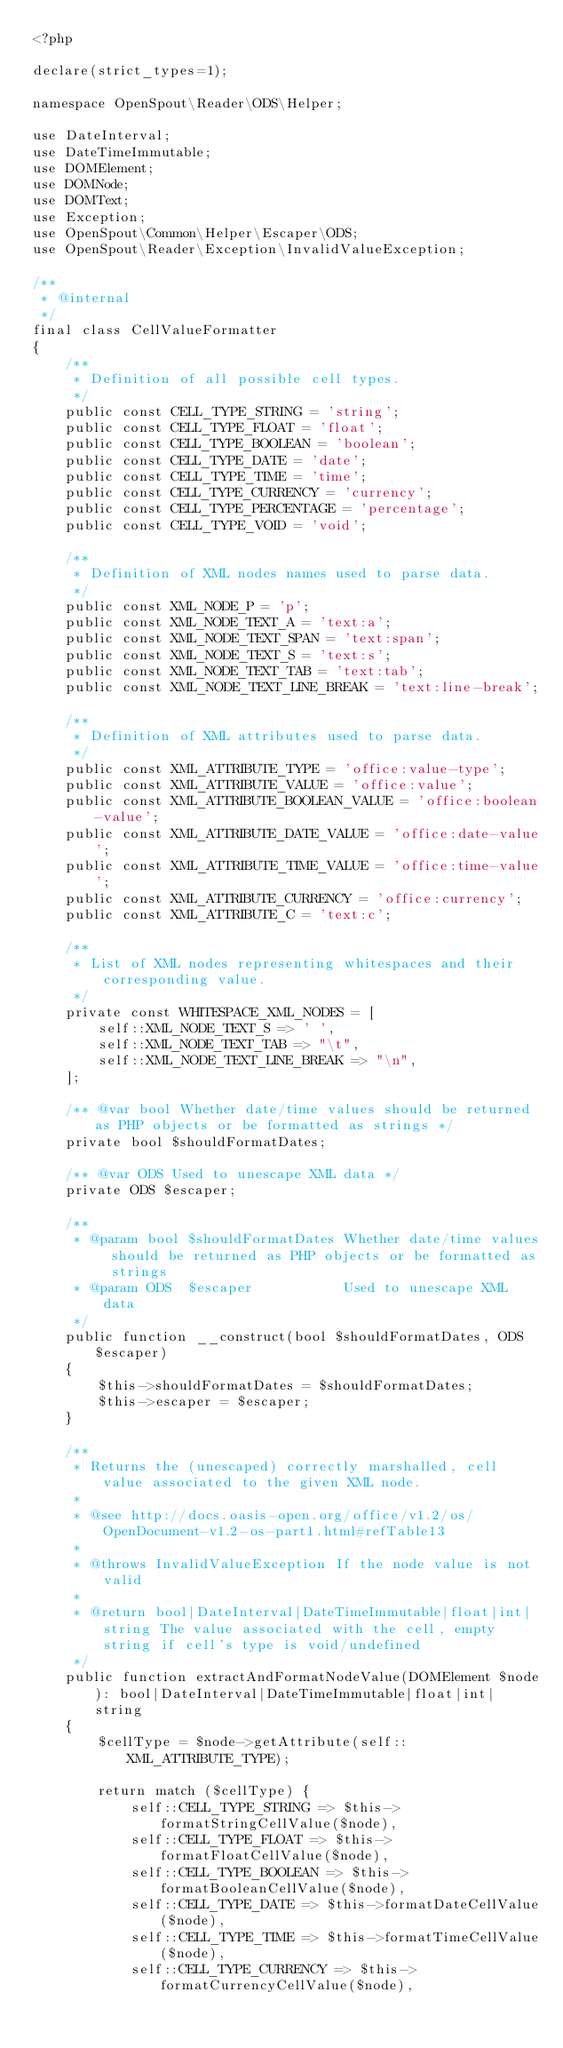Convert code to text. <code><loc_0><loc_0><loc_500><loc_500><_PHP_><?php

declare(strict_types=1);

namespace OpenSpout\Reader\ODS\Helper;

use DateInterval;
use DateTimeImmutable;
use DOMElement;
use DOMNode;
use DOMText;
use Exception;
use OpenSpout\Common\Helper\Escaper\ODS;
use OpenSpout\Reader\Exception\InvalidValueException;

/**
 * @internal
 */
final class CellValueFormatter
{
    /**
     * Definition of all possible cell types.
     */
    public const CELL_TYPE_STRING = 'string';
    public const CELL_TYPE_FLOAT = 'float';
    public const CELL_TYPE_BOOLEAN = 'boolean';
    public const CELL_TYPE_DATE = 'date';
    public const CELL_TYPE_TIME = 'time';
    public const CELL_TYPE_CURRENCY = 'currency';
    public const CELL_TYPE_PERCENTAGE = 'percentage';
    public const CELL_TYPE_VOID = 'void';

    /**
     * Definition of XML nodes names used to parse data.
     */
    public const XML_NODE_P = 'p';
    public const XML_NODE_TEXT_A = 'text:a';
    public const XML_NODE_TEXT_SPAN = 'text:span';
    public const XML_NODE_TEXT_S = 'text:s';
    public const XML_NODE_TEXT_TAB = 'text:tab';
    public const XML_NODE_TEXT_LINE_BREAK = 'text:line-break';

    /**
     * Definition of XML attributes used to parse data.
     */
    public const XML_ATTRIBUTE_TYPE = 'office:value-type';
    public const XML_ATTRIBUTE_VALUE = 'office:value';
    public const XML_ATTRIBUTE_BOOLEAN_VALUE = 'office:boolean-value';
    public const XML_ATTRIBUTE_DATE_VALUE = 'office:date-value';
    public const XML_ATTRIBUTE_TIME_VALUE = 'office:time-value';
    public const XML_ATTRIBUTE_CURRENCY = 'office:currency';
    public const XML_ATTRIBUTE_C = 'text:c';

    /**
     * List of XML nodes representing whitespaces and their corresponding value.
     */
    private const WHITESPACE_XML_NODES = [
        self::XML_NODE_TEXT_S => ' ',
        self::XML_NODE_TEXT_TAB => "\t",
        self::XML_NODE_TEXT_LINE_BREAK => "\n",
    ];

    /** @var bool Whether date/time values should be returned as PHP objects or be formatted as strings */
    private bool $shouldFormatDates;

    /** @var ODS Used to unescape XML data */
    private ODS $escaper;

    /**
     * @param bool $shouldFormatDates Whether date/time values should be returned as PHP objects or be formatted as strings
     * @param ODS  $escaper           Used to unescape XML data
     */
    public function __construct(bool $shouldFormatDates, ODS $escaper)
    {
        $this->shouldFormatDates = $shouldFormatDates;
        $this->escaper = $escaper;
    }

    /**
     * Returns the (unescaped) correctly marshalled, cell value associated to the given XML node.
     *
     * @see http://docs.oasis-open.org/office/v1.2/os/OpenDocument-v1.2-os-part1.html#refTable13
     *
     * @throws InvalidValueException If the node value is not valid
     *
     * @return bool|DateInterval|DateTimeImmutable|float|int|string The value associated with the cell, empty string if cell's type is void/undefined
     */
    public function extractAndFormatNodeValue(DOMElement $node): bool|DateInterval|DateTimeImmutable|float|int|string
    {
        $cellType = $node->getAttribute(self::XML_ATTRIBUTE_TYPE);

        return match ($cellType) {
            self::CELL_TYPE_STRING => $this->formatStringCellValue($node),
            self::CELL_TYPE_FLOAT => $this->formatFloatCellValue($node),
            self::CELL_TYPE_BOOLEAN => $this->formatBooleanCellValue($node),
            self::CELL_TYPE_DATE => $this->formatDateCellValue($node),
            self::CELL_TYPE_TIME => $this->formatTimeCellValue($node),
            self::CELL_TYPE_CURRENCY => $this->formatCurrencyCellValue($node),</code> 